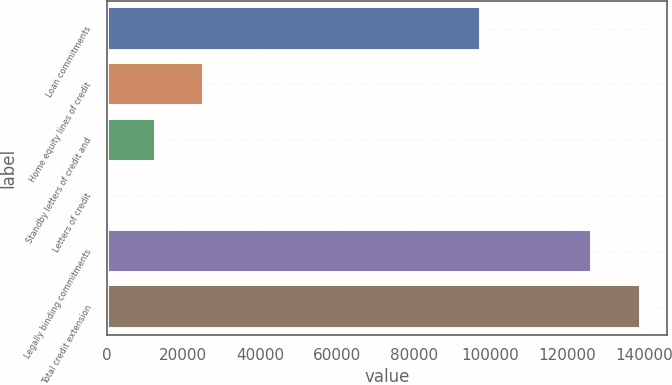<chart> <loc_0><loc_0><loc_500><loc_500><bar_chart><fcel>Loan commitments<fcel>Home equity lines of credit<fcel>Standby letters of credit and<fcel>Letters of credit<fcel>Legally binding commitments<fcel>Total credit extension<nl><fcel>97583<fcel>25430.6<fcel>12793.8<fcel>157<fcel>126525<fcel>139162<nl></chart> 